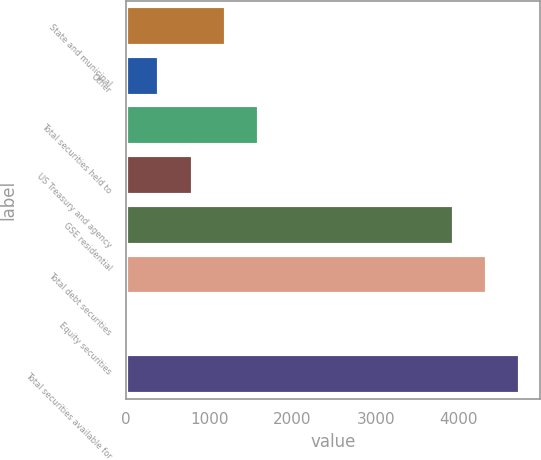Convert chart to OTSL. <chart><loc_0><loc_0><loc_500><loc_500><bar_chart><fcel>State and municipal<fcel>Other<fcel>Total securities held to<fcel>US Treasury and agency<fcel>GSE residential<fcel>Total debt securities<fcel>Equity securities<fcel>Total securities available for<nl><fcel>1198.25<fcel>399.55<fcel>1597.6<fcel>798.9<fcel>3936.7<fcel>4336.05<fcel>0.2<fcel>4735.4<nl></chart> 